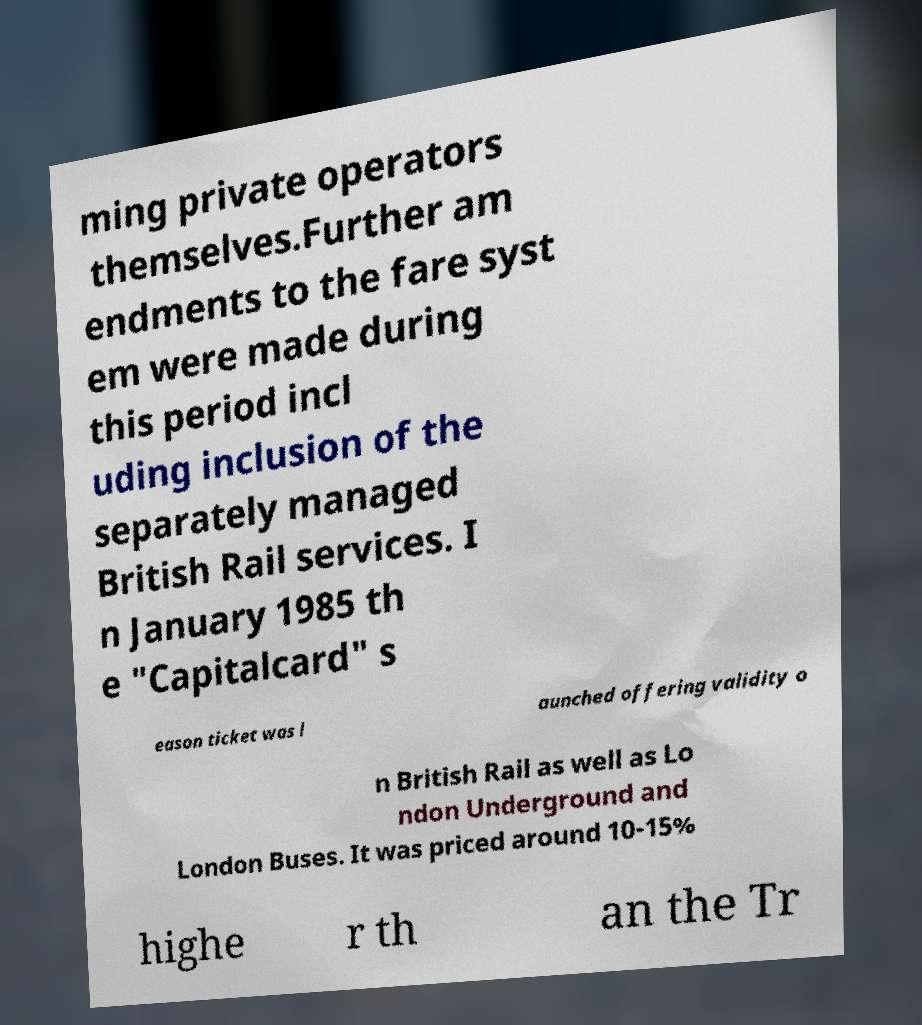What messages or text are displayed in this image? I need them in a readable, typed format. ming private operators themselves.Further am endments to the fare syst em were made during this period incl uding inclusion of the separately managed British Rail services. I n January 1985 th e "Capitalcard" s eason ticket was l aunched offering validity o n British Rail as well as Lo ndon Underground and London Buses. It was priced around 10-15% highe r th an the Tr 